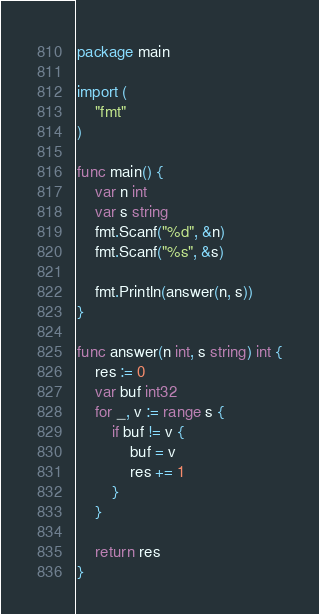<code> <loc_0><loc_0><loc_500><loc_500><_Go_>package main

import (
	"fmt"
)

func main() {
	var n int
	var s string
	fmt.Scanf("%d", &n)
	fmt.Scanf("%s", &s)

	fmt.Println(answer(n, s))
}

func answer(n int, s string) int {
	res := 0
	var buf int32
	for _, v := range s {
		if buf != v {
			buf = v
			res += 1
		}
	}

	return res
}

</code> 